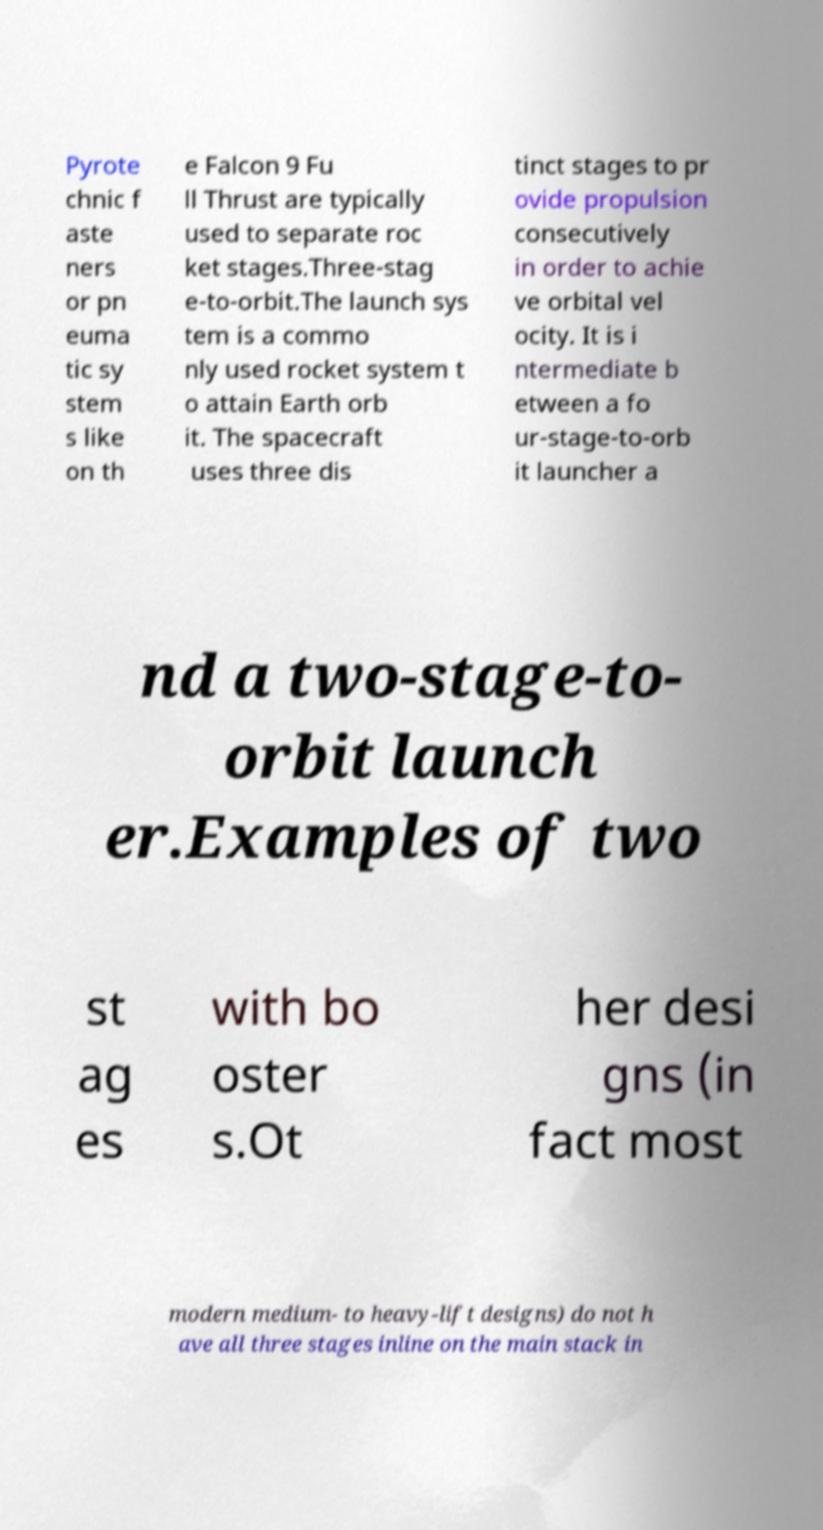I need the written content from this picture converted into text. Can you do that? Pyrote chnic f aste ners or pn euma tic sy stem s like on th e Falcon 9 Fu ll Thrust are typically used to separate roc ket stages.Three-stag e-to-orbit.The launch sys tem is a commo nly used rocket system t o attain Earth orb it. The spacecraft uses three dis tinct stages to pr ovide propulsion consecutively in order to achie ve orbital vel ocity. It is i ntermediate b etween a fo ur-stage-to-orb it launcher a nd a two-stage-to- orbit launch er.Examples of two st ag es with bo oster s.Ot her desi gns (in fact most modern medium- to heavy-lift designs) do not h ave all three stages inline on the main stack in 